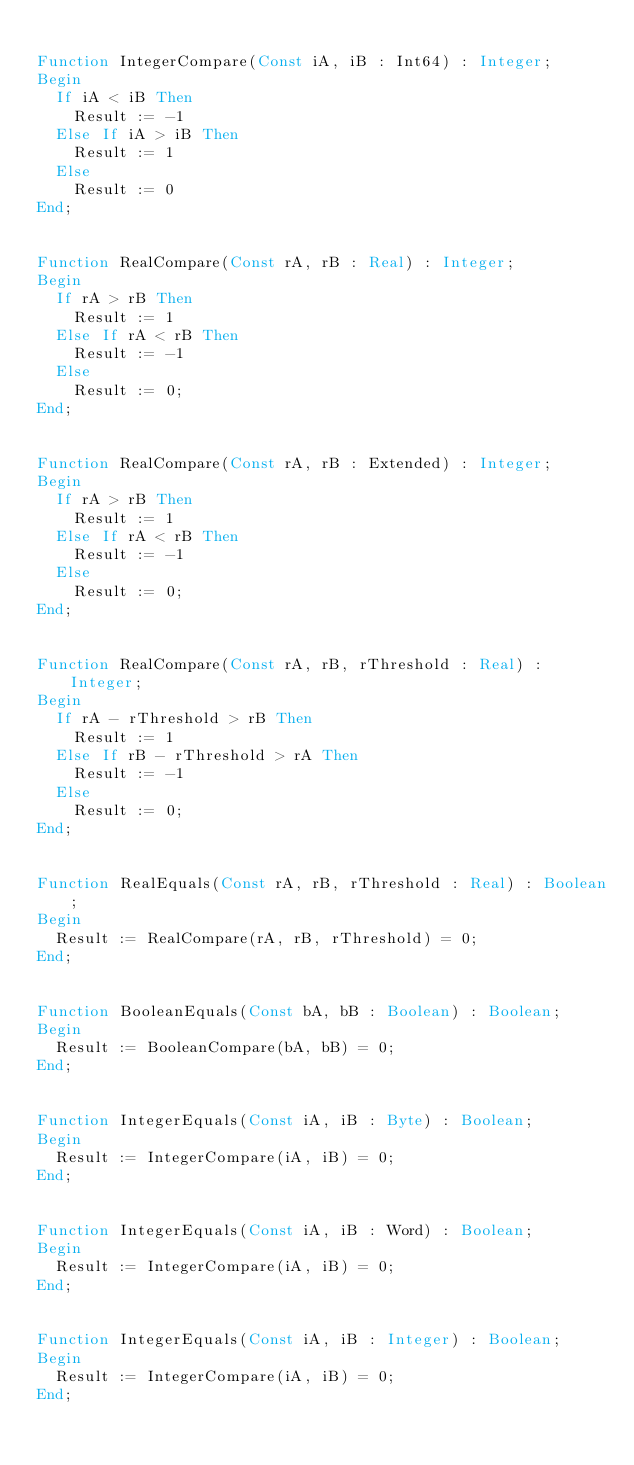<code> <loc_0><loc_0><loc_500><loc_500><_Pascal_>
Function IntegerCompare(Const iA, iB : Int64) : Integer;
Begin
  If iA < iB Then
    Result := -1
  Else If iA > iB Then
    Result := 1
  Else
    Result := 0
End;


Function RealCompare(Const rA, rB : Real) : Integer;
Begin
  If rA > rB Then
    Result := 1
  Else If rA < rB Then
    Result := -1
  Else
    Result := 0;
End;


Function RealCompare(Const rA, rB : Extended) : Integer;
Begin
  If rA > rB Then
    Result := 1
  Else If rA < rB Then
    Result := -1
  Else
    Result := 0;
End;


Function RealCompare(Const rA, rB, rThreshold : Real) : Integer;
Begin
  If rA - rThreshold > rB Then
    Result := 1
  Else If rB - rThreshold > rA Then
    Result := -1
  Else
    Result := 0;
End;  


Function RealEquals(Const rA, rB, rThreshold : Real) : Boolean;
Begin 
  Result := RealCompare(rA, rB, rThreshold) = 0;
End;  


Function BooleanEquals(Const bA, bB : Boolean) : Boolean;
Begin 
  Result := BooleanCompare(bA, bB) = 0;
End;


Function IntegerEquals(Const iA, iB : Byte) : Boolean;
Begin
  Result := IntegerCompare(iA, iB) = 0;
End;


Function IntegerEquals(Const iA, iB : Word) : Boolean;
Begin
  Result := IntegerCompare(iA, iB) = 0;
End;


Function IntegerEquals(Const iA, iB : Integer) : Boolean;
Begin
  Result := IntegerCompare(iA, iB) = 0;
End;

</code> 